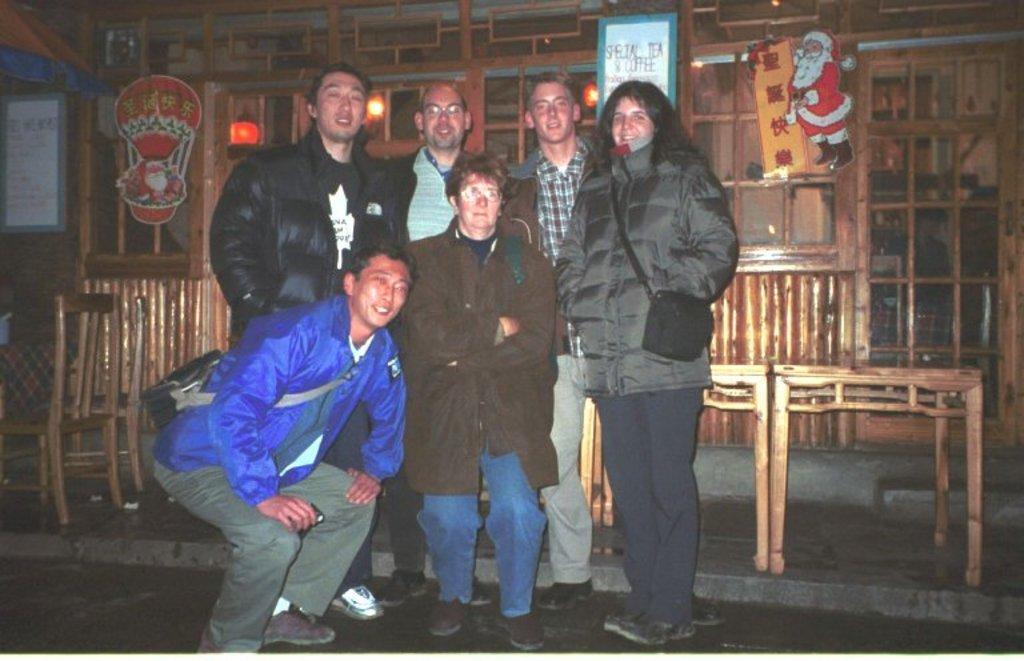Please provide a concise description of this image. In this image I can see group of people standing. The person standing in front wearing brown jacket, blue pant. I can also see few persons wearing bag, at the back I can see few chairs in brown color and wall in brown color. I can also see a frame attached to the pole. 